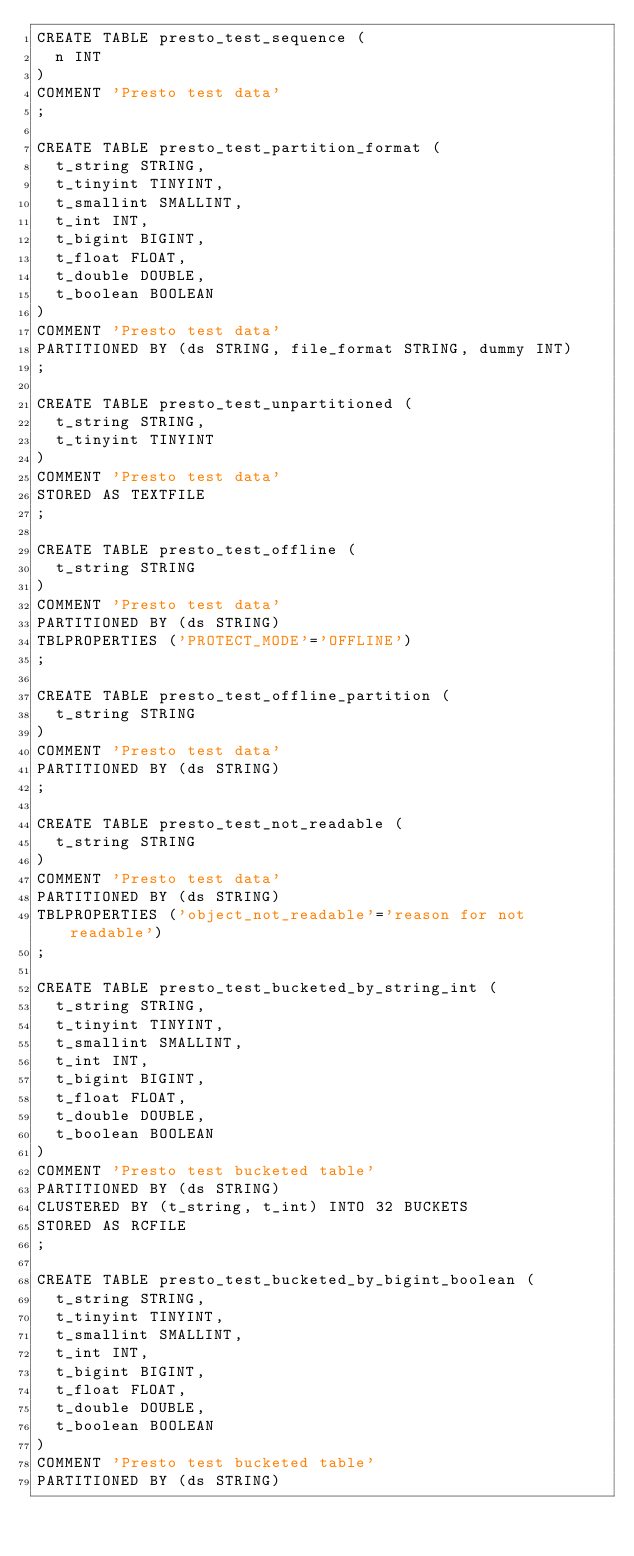Convert code to text. <code><loc_0><loc_0><loc_500><loc_500><_SQL_>CREATE TABLE presto_test_sequence (
  n INT
)
COMMENT 'Presto test data'
;

CREATE TABLE presto_test_partition_format (
  t_string STRING,
  t_tinyint TINYINT,
  t_smallint SMALLINT,
  t_int INT,
  t_bigint BIGINT,
  t_float FLOAT,
  t_double DOUBLE,
  t_boolean BOOLEAN
)
COMMENT 'Presto test data'
PARTITIONED BY (ds STRING, file_format STRING, dummy INT)
;

CREATE TABLE presto_test_unpartitioned (
  t_string STRING,
  t_tinyint TINYINT
)
COMMENT 'Presto test data'
STORED AS TEXTFILE
;

CREATE TABLE presto_test_offline (
  t_string STRING
)
COMMENT 'Presto test data'
PARTITIONED BY (ds STRING)
TBLPROPERTIES ('PROTECT_MODE'='OFFLINE')
;

CREATE TABLE presto_test_offline_partition (
  t_string STRING
)
COMMENT 'Presto test data'
PARTITIONED BY (ds STRING)
;

CREATE TABLE presto_test_not_readable (
  t_string STRING
)
COMMENT 'Presto test data'
PARTITIONED BY (ds STRING)
TBLPROPERTIES ('object_not_readable'='reason for not readable')
;

CREATE TABLE presto_test_bucketed_by_string_int (
  t_string STRING,
  t_tinyint TINYINT,
  t_smallint SMALLINT,
  t_int INT,
  t_bigint BIGINT,
  t_float FLOAT,
  t_double DOUBLE,
  t_boolean BOOLEAN
)
COMMENT 'Presto test bucketed table'
PARTITIONED BY (ds STRING)
CLUSTERED BY (t_string, t_int) INTO 32 BUCKETS
STORED AS RCFILE
;

CREATE TABLE presto_test_bucketed_by_bigint_boolean (
  t_string STRING,
  t_tinyint TINYINT,
  t_smallint SMALLINT,
  t_int INT,
  t_bigint BIGINT,
  t_float FLOAT,
  t_double DOUBLE,
  t_boolean BOOLEAN
)
COMMENT 'Presto test bucketed table'
PARTITIONED BY (ds STRING)</code> 